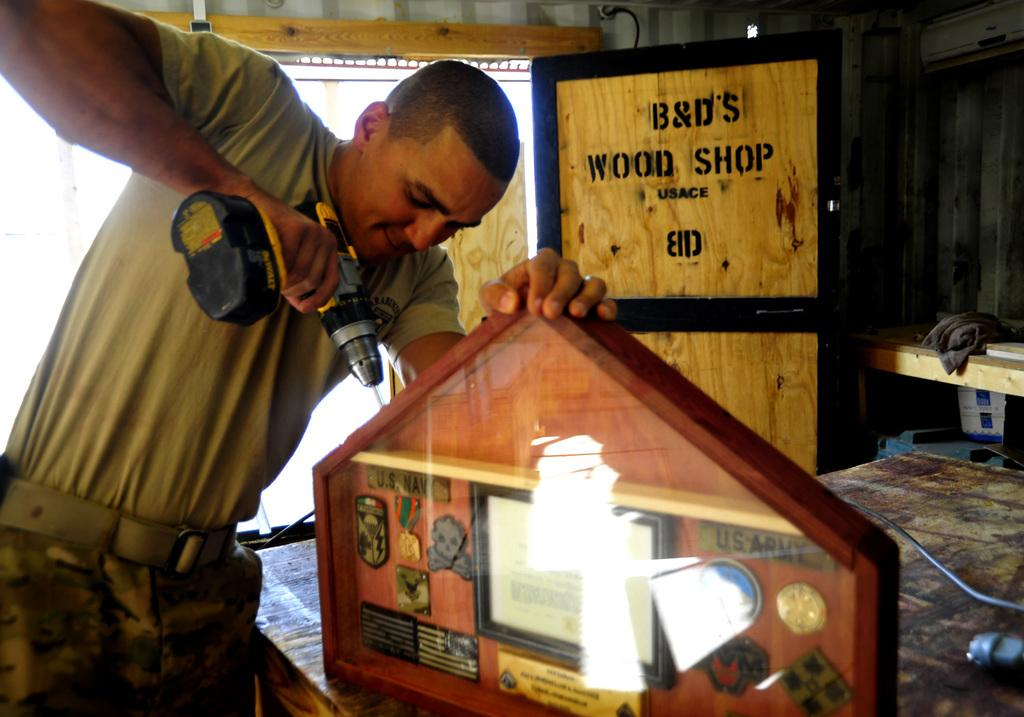Provide a one-sentence caption for the provided image. A man using a drill on piece of wood from B&D's Wood Shop. 